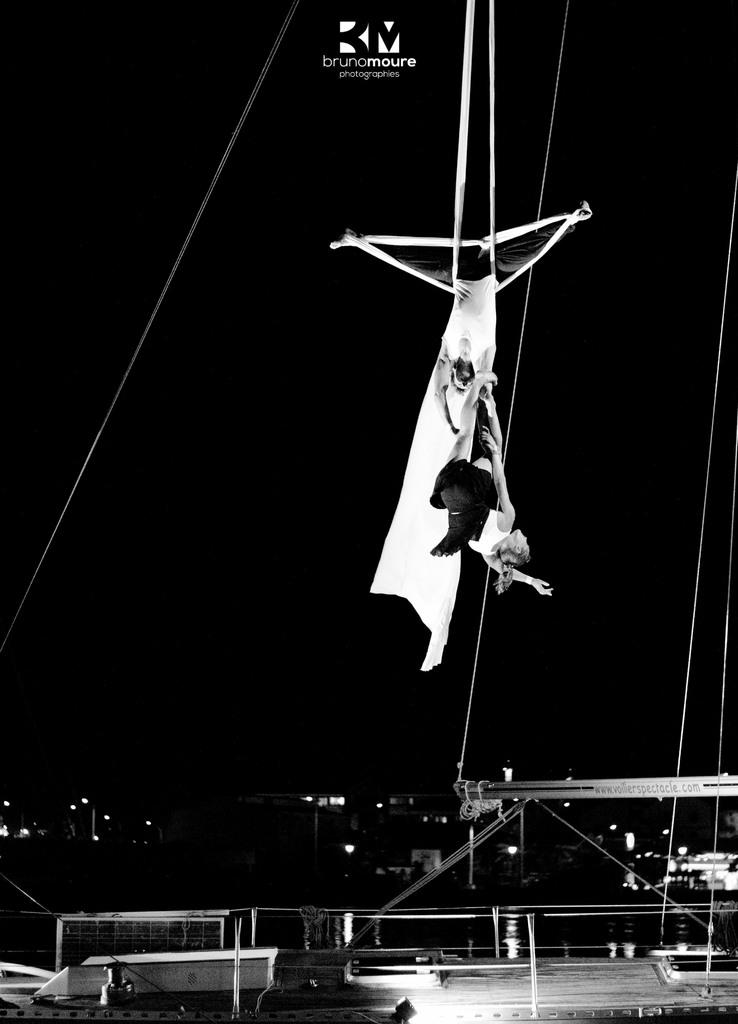What activity are the people in the image engaged in? The people in the image are performing gymnastics. Can you describe any additional features of the image? There is a watermark on the top of the image. What can be seen in the background of the image? There are buildings visible in the image. What verse is being recited by the gymnasts in the image? There is no indication in the image that the gymnasts are reciting a verse, as they are focused on performing gymnastics. 